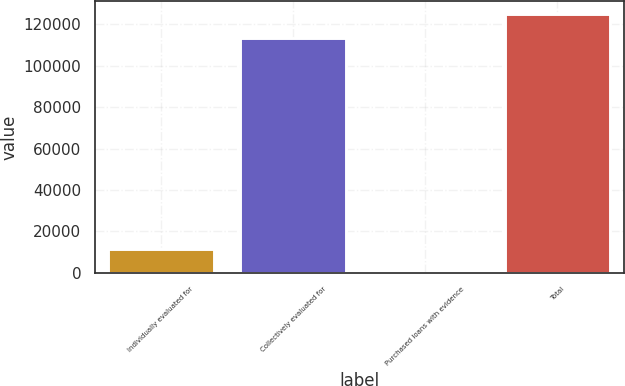Convert chart to OTSL. <chart><loc_0><loc_0><loc_500><loc_500><bar_chart><fcel>Individually evaluated for<fcel>Collectively evaluated for<fcel>Purchased loans with evidence<fcel>Total<nl><fcel>11687.2<fcel>113202<fcel>105<fcel>124784<nl></chart> 